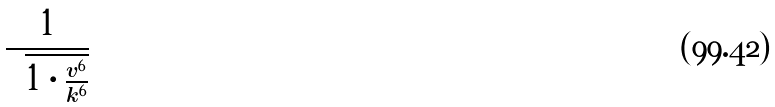<formula> <loc_0><loc_0><loc_500><loc_500>\frac { 1 } { \sqrt { 1 \cdot \frac { v ^ { 6 } } { k ^ { 6 } } } }</formula> 